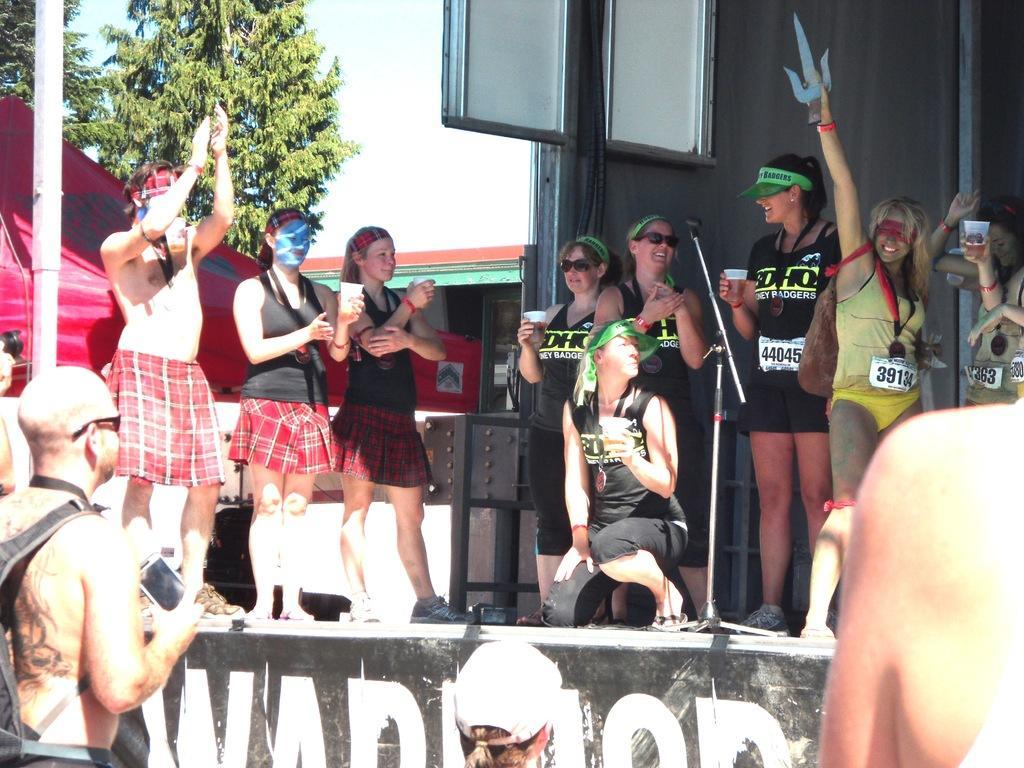How would you summarize this image in a sentence or two? In this image I can see few persons standing in front of the stage, the stage, few persons standing on the stage and a woman sitting on the stage. I can see few of them are holding cups in their hands. In the background I can see few trees which are green in color, a red colored tent, a building and the sky. 